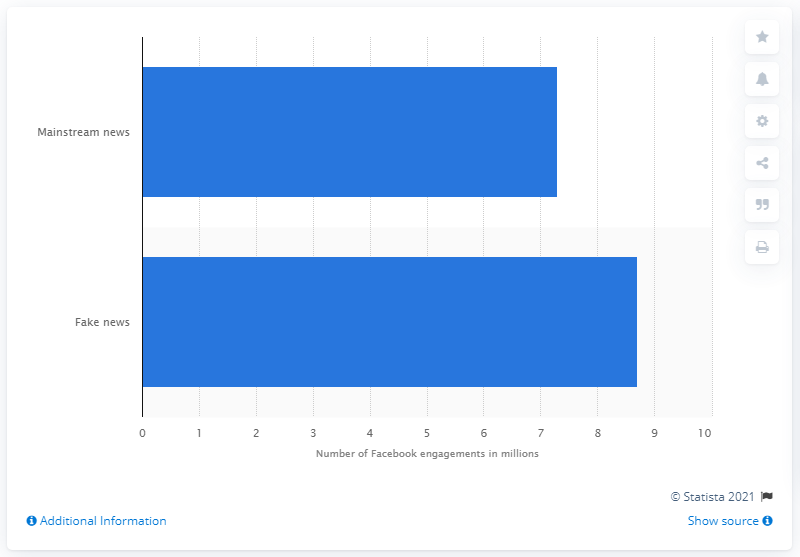Point out several critical features in this image. There were 8.7 Facebook engagements for fake news stories about the election. In 2016, mainstream news stories on Facebook received an average of 7,300 engagements per story. 